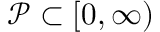<formula> <loc_0><loc_0><loc_500><loc_500>\mathcal { P } \subset [ 0 , \infty )</formula> 